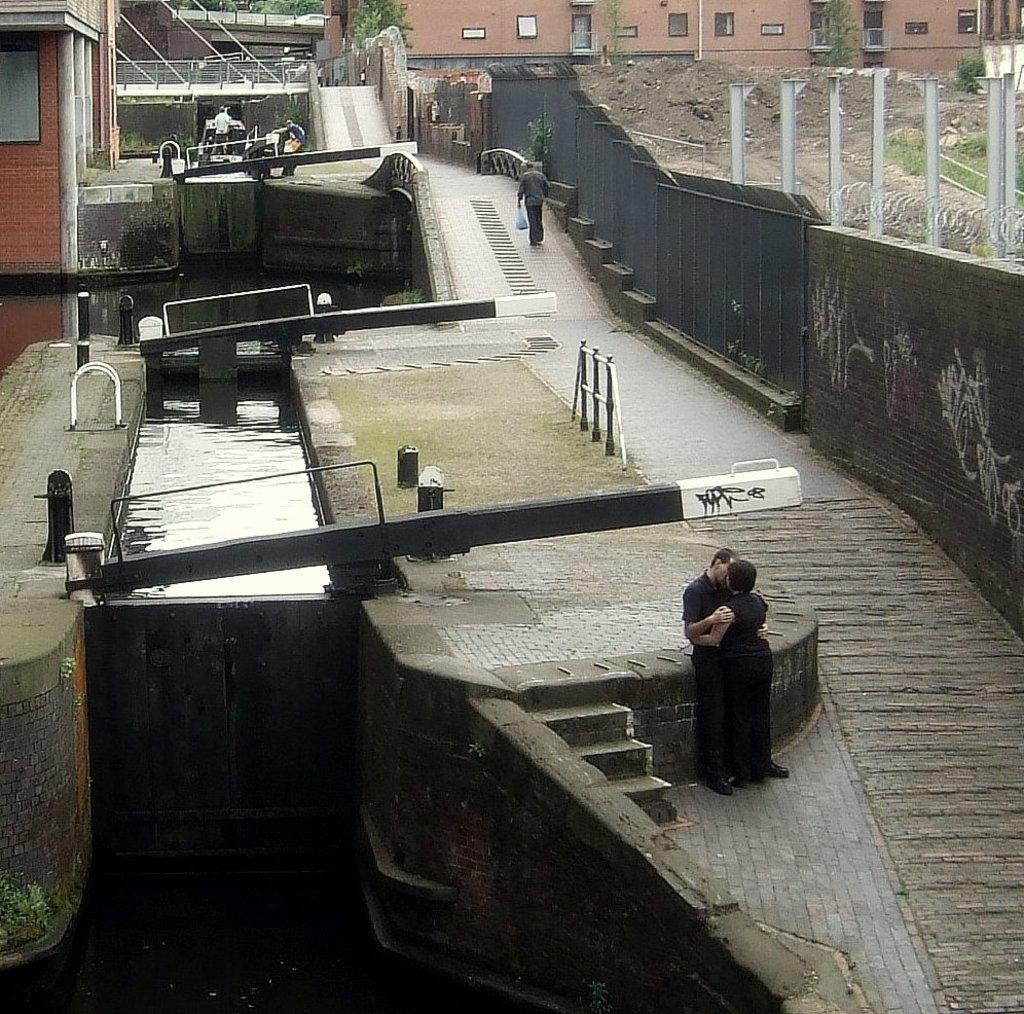How many people are present in the image? There are two people standing in the image. What else can be seen in the background of the image? There are other houses visible in the image. What objects are present in the image that might be used for supporting or holding something? There are poles in the image. What objects are present in the image that might be used for cooking or grilling food? There are grills in the image. What natural element is visible in the image? There is water visible in the image. What type of jelly can be seen on the grills in the image? There is no jelly present on the grills in the image; there are only grills visible. Can you describe the snail that is crawling on the water in the image? There is no snail present in the image; there is only water visible. 